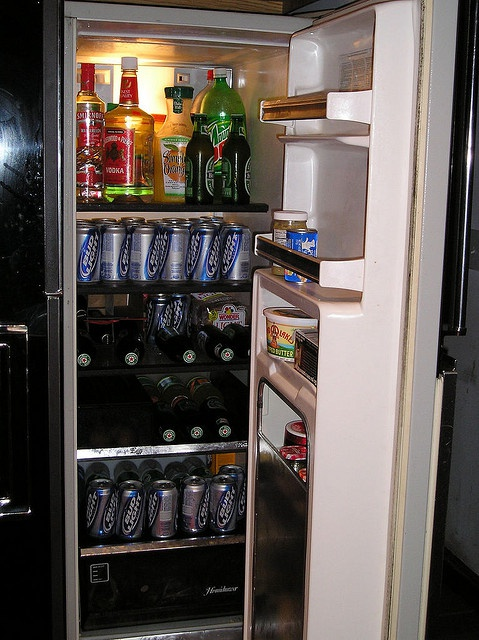Describe the objects in this image and their specific colors. I can see refrigerator in black, darkgray, lightgray, and gray tones, bottle in black, gray, darkgray, and lightgray tones, bottle in black, maroon, and brown tones, bottle in black, brown, olive, and darkgray tones, and bottle in black, maroon, and brown tones in this image. 